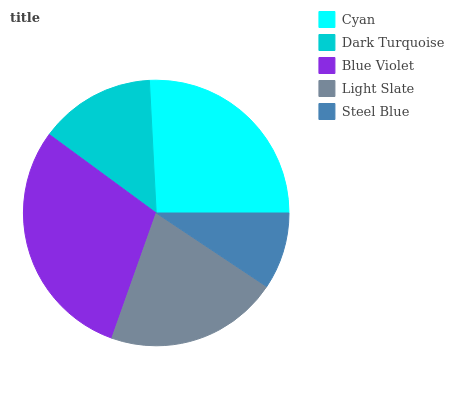Is Steel Blue the minimum?
Answer yes or no. Yes. Is Blue Violet the maximum?
Answer yes or no. Yes. Is Dark Turquoise the minimum?
Answer yes or no. No. Is Dark Turquoise the maximum?
Answer yes or no. No. Is Cyan greater than Dark Turquoise?
Answer yes or no. Yes. Is Dark Turquoise less than Cyan?
Answer yes or no. Yes. Is Dark Turquoise greater than Cyan?
Answer yes or no. No. Is Cyan less than Dark Turquoise?
Answer yes or no. No. Is Light Slate the high median?
Answer yes or no. Yes. Is Light Slate the low median?
Answer yes or no. Yes. Is Steel Blue the high median?
Answer yes or no. No. Is Blue Violet the low median?
Answer yes or no. No. 